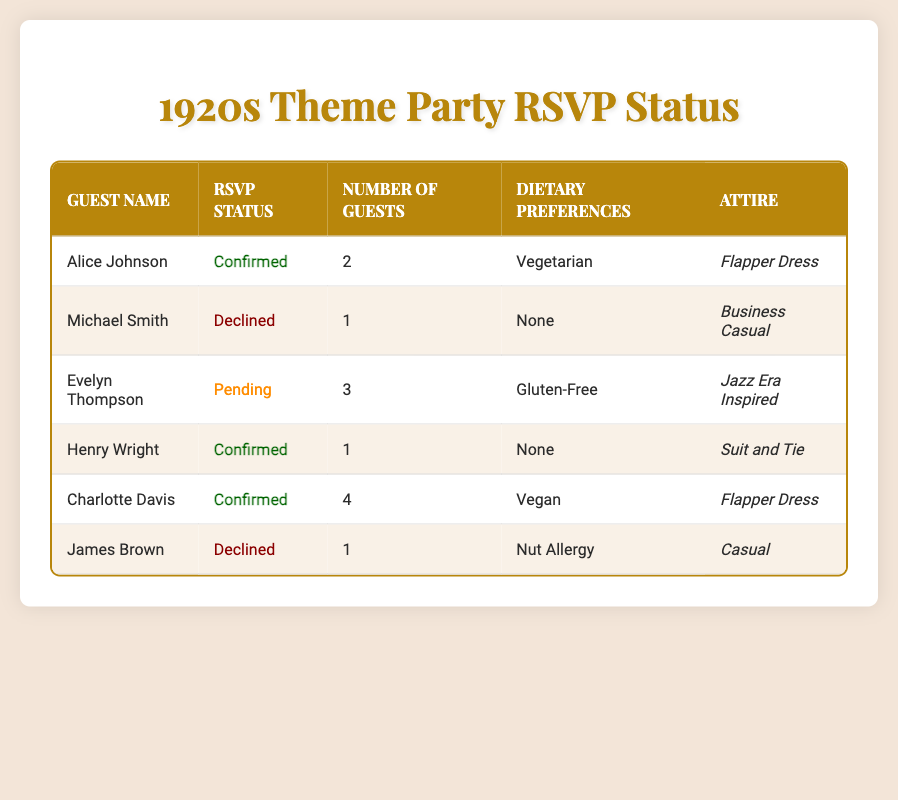What is the RSVP status of Alice Johnson? In the table, the row for Alice Johnson indicates that her RSVP status is "Confirmed."
Answer: Confirmed How many guests will Charlotte Davis bring to the party? The table shows that Charlotte Davis has indicated she will bring 4 guests.
Answer: 4 Are there any guests with a dietary preference for gluten-free food? Looking at the dietary preferences column, only Evelyn Thompson has specified "Gluten-Free."
Answer: Yes What is the total number of guests confirmed to attend the party? The confirmed guests are Alice Johnson (2 guests), Henry Wright (1 guest), and Charlotte Davis (4 guests). Adding them gives: 2 + 1 + 4 = 7 confirmed guests.
Answer: 7 Which attire is most commonly worn by confirmed guests? The confirmed guests are Alice Johnson (Flapper Dress), Henry Wright (Suit and Tie), and Charlotte Davis (Flapper Dress). The Flapper Dress is worn by 2 of the 3 confirmed guests, making it the most common attire among them.
Answer: Flapper Dress Is there anyone who has declined to attend the party? The table lists Michael Smith and James Brown as guests who have declined their invitation.
Answer: Yes What is the total number of guests indicated by all guests? Adding the number of guests for each respondent: Alice Johnson (2) + Michael Smith (1) + Evelyn Thompson (3) + Henry Wright (1) + Charlotte Davis (4) + James Brown (1) = 12 total guests.
Answer: 12 How many guests have a dietary preference listed as "None"? The table shows that both Michael Smith and Henry Wright listed dietary preference as "None." Counting them gives a total of 2 guests.
Answer: 2 If Evelyn Thompson confirms her RSVP, how many total guests would there be? Currently, 12 guests are indicated. If Evelyn Thompson's group of 3 guests is added upon confirmation, the total becomes 12 + 3 = 15 guests.
Answer: 15 